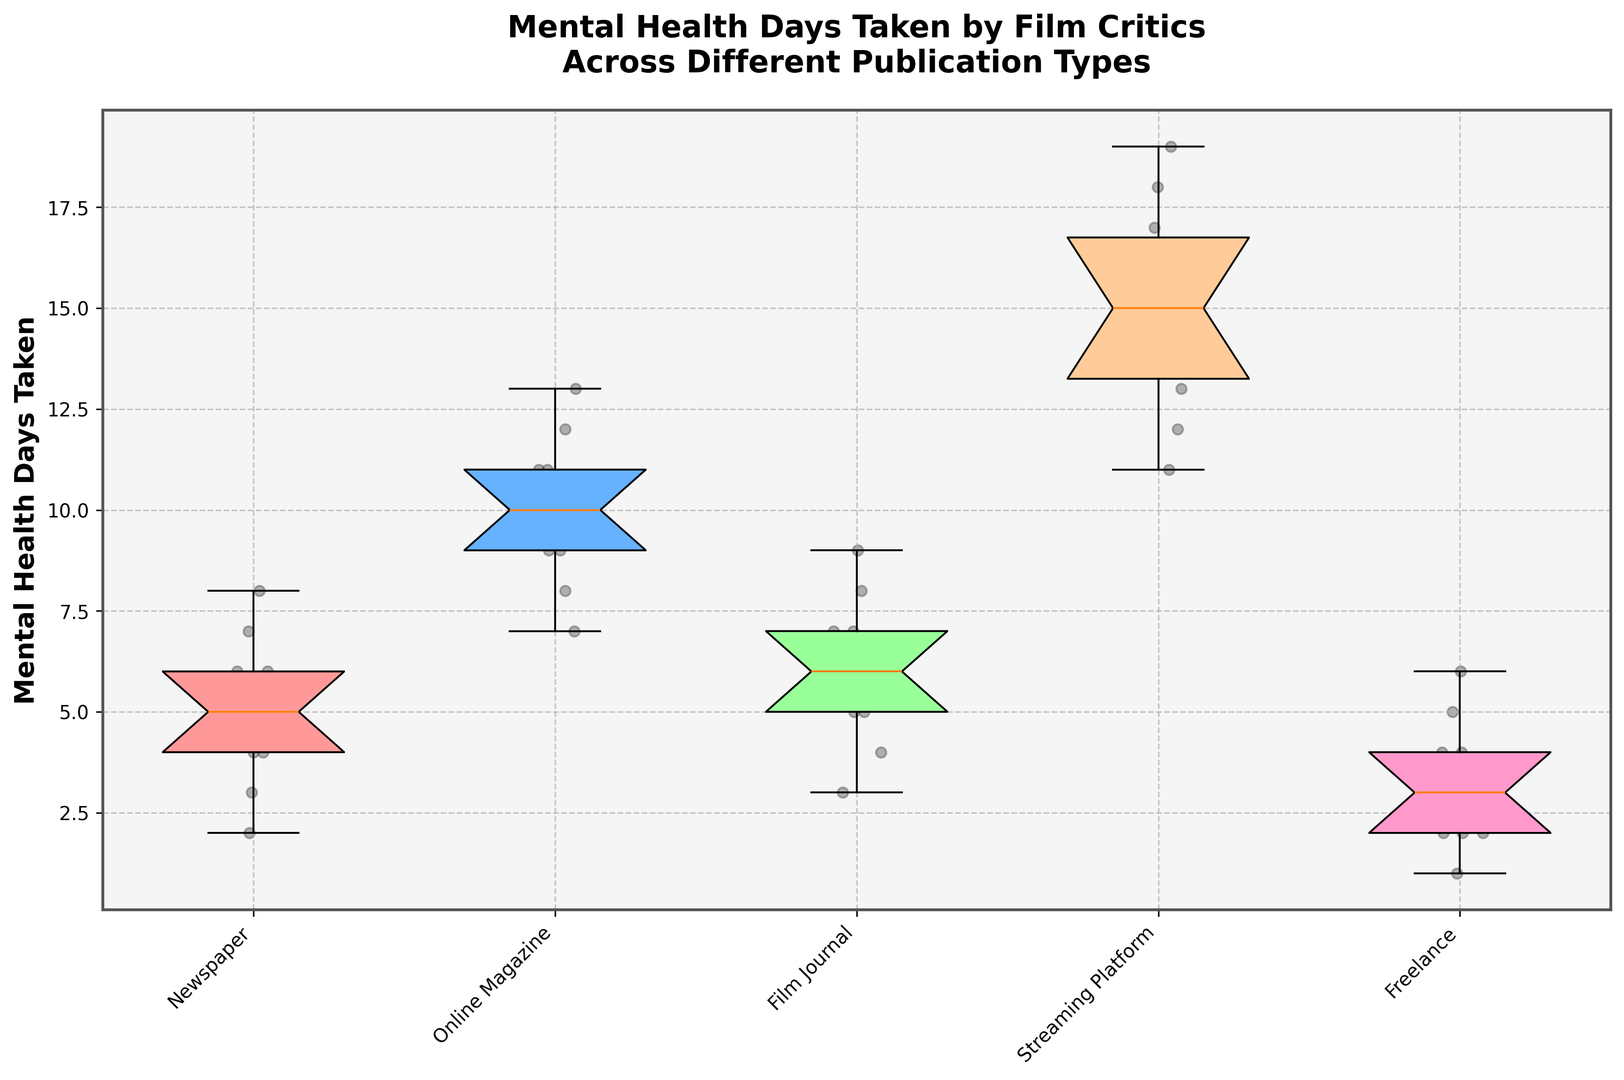What's the median mental health days taken for Online Magazine critics? Locate the Online Magazine box plot. The median is the line inside the box. It looks like the median is at 10.
Answer: 10 Which publication type has the highest median mental health days taken? Compare the median lines of all box plots. The box plot for Streaming Platform has the highest median.
Answer: Streaming Platform Are there any outliers in the Freelance group? Check for any points that fall outside the whiskers for the Freelance box plot. There are no points outside the whiskers.
Answer: No Which group has a wider range of mental health days taken: Newspaper or Film Journal? Compare the length of the boxes (the distance between the lower and upper whiskers) for Newspaper and Film Journal. Newspaper has a wider range.
Answer: Newspaper How many types of publication have a median mental health days taken less than 7? Identify the median lines of all box plots and count those that are below 7. Three groups have medians below 7: Newspaper, Film Journal, and Freelance.
Answer: 3 What is the interquartile range (IQR) for Streaming Platform critics? The IQR is the difference between the 75th percentile (top of the box) and the 25th percentile (bottom of the box). For Streaming Platform, the IQR is 17 - 12 = 5.
Answer: 5 How does the median of Online Magazine compare to Film Journal? Compare the median lines of both box plots. The median of Online Magazine (10) is higher than Film Journal (6).
Answer: Higher Which publication type has the most symmetrical distribution of taken mental health days? Symmetry is indicated by the median being near the center of the box and whiskers being similar in length. Streaming Platform appears the most symmetrical.
Answer: Streaming Platform What is the range of mental health days taken for Freelance critics? The range is the difference between the maximum and minimum values. For Freelance, it is 6 - 1 = 5.
Answer: 5 